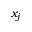<formula> <loc_0><loc_0><loc_500><loc_500>x _ { j }</formula> 